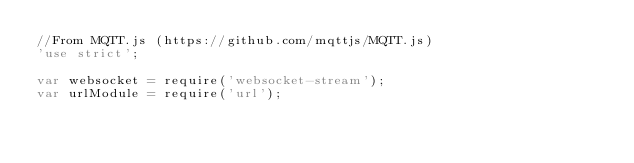Convert code to text. <code><loc_0><loc_0><loc_500><loc_500><_JavaScript_>//From MQTT.js (https://github.com/mqttjs/MQTT.js)
'use strict';

var websocket = require('websocket-stream');
var urlModule = require('url');</code> 